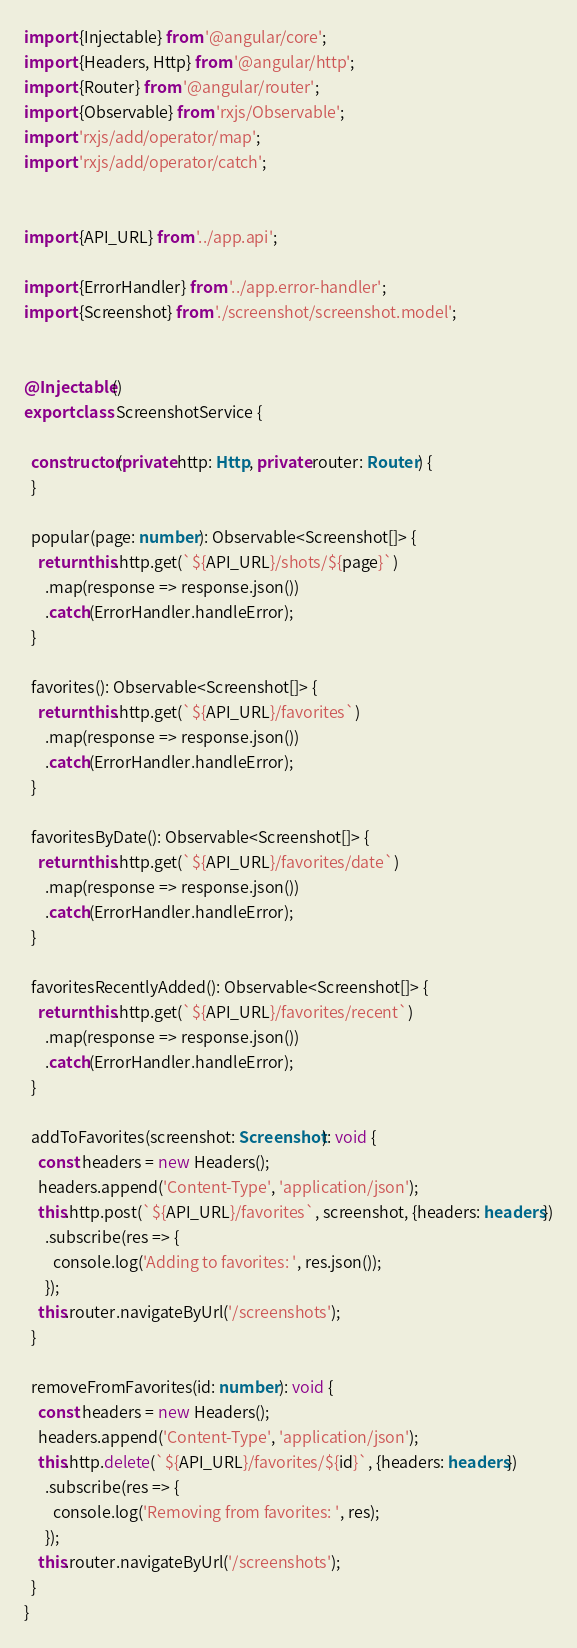<code> <loc_0><loc_0><loc_500><loc_500><_TypeScript_>import {Injectable} from '@angular/core';
import {Headers, Http} from '@angular/http';
import {Router} from '@angular/router';
import {Observable} from 'rxjs/Observable';
import 'rxjs/add/operator/map';
import 'rxjs/add/operator/catch';


import {API_URL} from '../app.api';

import {ErrorHandler} from '../app.error-handler';
import {Screenshot} from './screenshot/screenshot.model';


@Injectable()
export class ScreenshotService {

  constructor(private http: Http, private router: Router) {
  }

  popular(page: number): Observable<Screenshot[]> {
    return this.http.get(`${API_URL}/shots/${page}`)
      .map(response => response.json())
      .catch(ErrorHandler.handleError);
  }

  favorites(): Observable<Screenshot[]> {
    return this.http.get(`${API_URL}/favorites`)
      .map(response => response.json())
      .catch(ErrorHandler.handleError);
  }

  favoritesByDate(): Observable<Screenshot[]> {
    return this.http.get(`${API_URL}/favorites/date`)
      .map(response => response.json())
      .catch(ErrorHandler.handleError);
  }

  favoritesRecentlyAdded(): Observable<Screenshot[]> {
    return this.http.get(`${API_URL}/favorites/recent`)
      .map(response => response.json())
      .catch(ErrorHandler.handleError);
  }

  addToFavorites(screenshot: Screenshot): void {
    const headers = new Headers();
    headers.append('Content-Type', 'application/json');
    this.http.post(`${API_URL}/favorites`, screenshot, {headers: headers})
      .subscribe(res => {
        console.log('Adding to favorites: ', res.json());
      });
    this.router.navigateByUrl('/screenshots');
  }

  removeFromFavorites(id: number): void {
    const headers = new Headers();
    headers.append('Content-Type', 'application/json');
    this.http.delete(`${API_URL}/favorites/${id}`, {headers: headers})
      .subscribe(res => {
        console.log('Removing from favorites: ', res);
      });
    this.router.navigateByUrl('/screenshots');
  }
}
</code> 